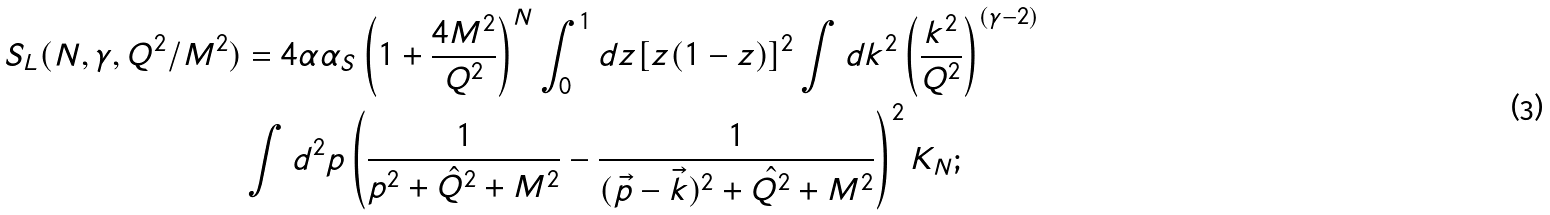<formula> <loc_0><loc_0><loc_500><loc_500>S _ { L } ( N , \gamma , Q ^ { 2 } / M ^ { 2 } ) & = 4 \alpha \alpha _ { S } \left ( 1 + \frac { 4 M ^ { 2 } } { Q ^ { 2 } } \right ) ^ { N } \int _ { 0 } ^ { 1 } d z [ z ( 1 - z ) ] ^ { 2 } \int d k ^ { 2 } \left ( \frac { k ^ { 2 } } { Q ^ { 2 } } \right ) ^ { ( \gamma - 2 ) } \\ & \int d ^ { 2 } p \left ( \frac { 1 } { p ^ { 2 } + \hat { Q } ^ { 2 } + M ^ { 2 } } - \frac { 1 } { ( \vec { p } - \vec { k } ) ^ { 2 } + \hat { Q ^ { 2 } } + M ^ { 2 } } \right ) ^ { 2 } K _ { N } ;</formula> 